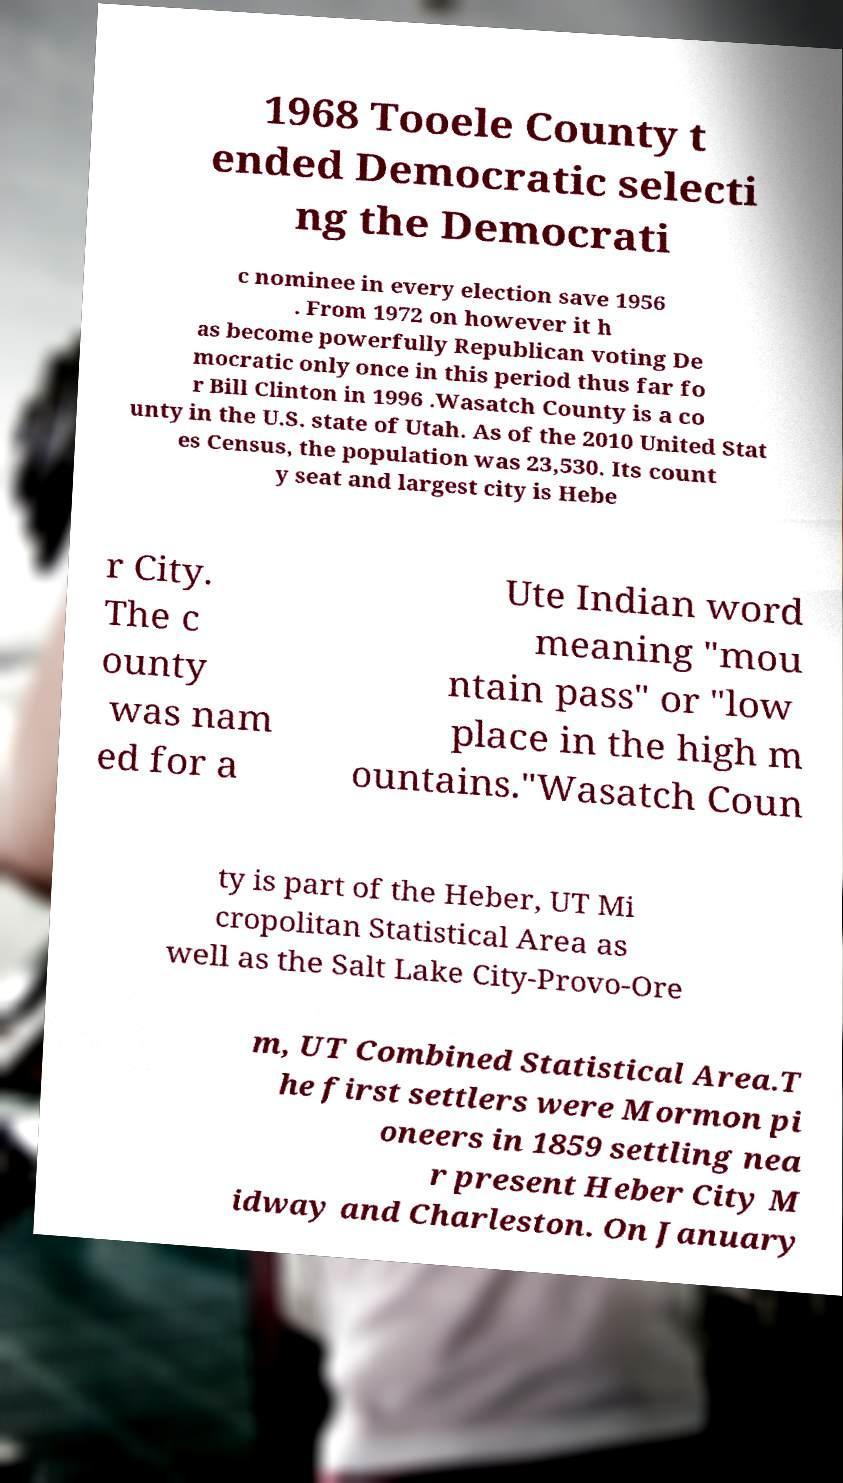What messages or text are displayed in this image? I need them in a readable, typed format. 1968 Tooele County t ended Democratic selecti ng the Democrati c nominee in every election save 1956 . From 1972 on however it h as become powerfully Republican voting De mocratic only once in this period thus far fo r Bill Clinton in 1996 .Wasatch County is a co unty in the U.S. state of Utah. As of the 2010 United Stat es Census, the population was 23,530. Its count y seat and largest city is Hebe r City. The c ounty was nam ed for a Ute Indian word meaning "mou ntain pass" or "low place in the high m ountains."Wasatch Coun ty is part of the Heber, UT Mi cropolitan Statistical Area as well as the Salt Lake City-Provo-Ore m, UT Combined Statistical Area.T he first settlers were Mormon pi oneers in 1859 settling nea r present Heber City M idway and Charleston. On January 